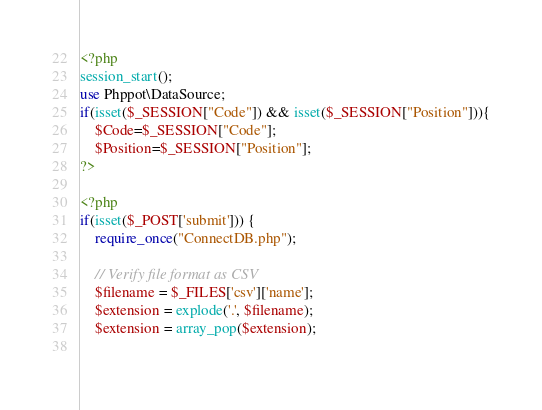<code> <loc_0><loc_0><loc_500><loc_500><_PHP_><?php
session_start();
use Phppot\DataSource;
if(isset($_SESSION["Code"]) && isset($_SESSION["Position"])){
	$Code=$_SESSION["Code"];
	$Position=$_SESSION["Position"];
?>

<?php
if(isset($_POST['submit'])) {
	require_once("ConnectDB.php");
 
	// Verify file format as CSV
	$filename = $_FILES['csv']['name'];
	$extension = explode('.', $filename);
	$extension = array_pop($extension);
        </code> 